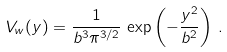Convert formula to latex. <formula><loc_0><loc_0><loc_500><loc_500>V _ { w } ( { y } ) = \frac { 1 } { b ^ { 3 } \pi ^ { 3 / 2 } } \, \exp \left ( - \frac { { y } ^ { 2 } } { b ^ { 2 } } \right ) \, .</formula> 